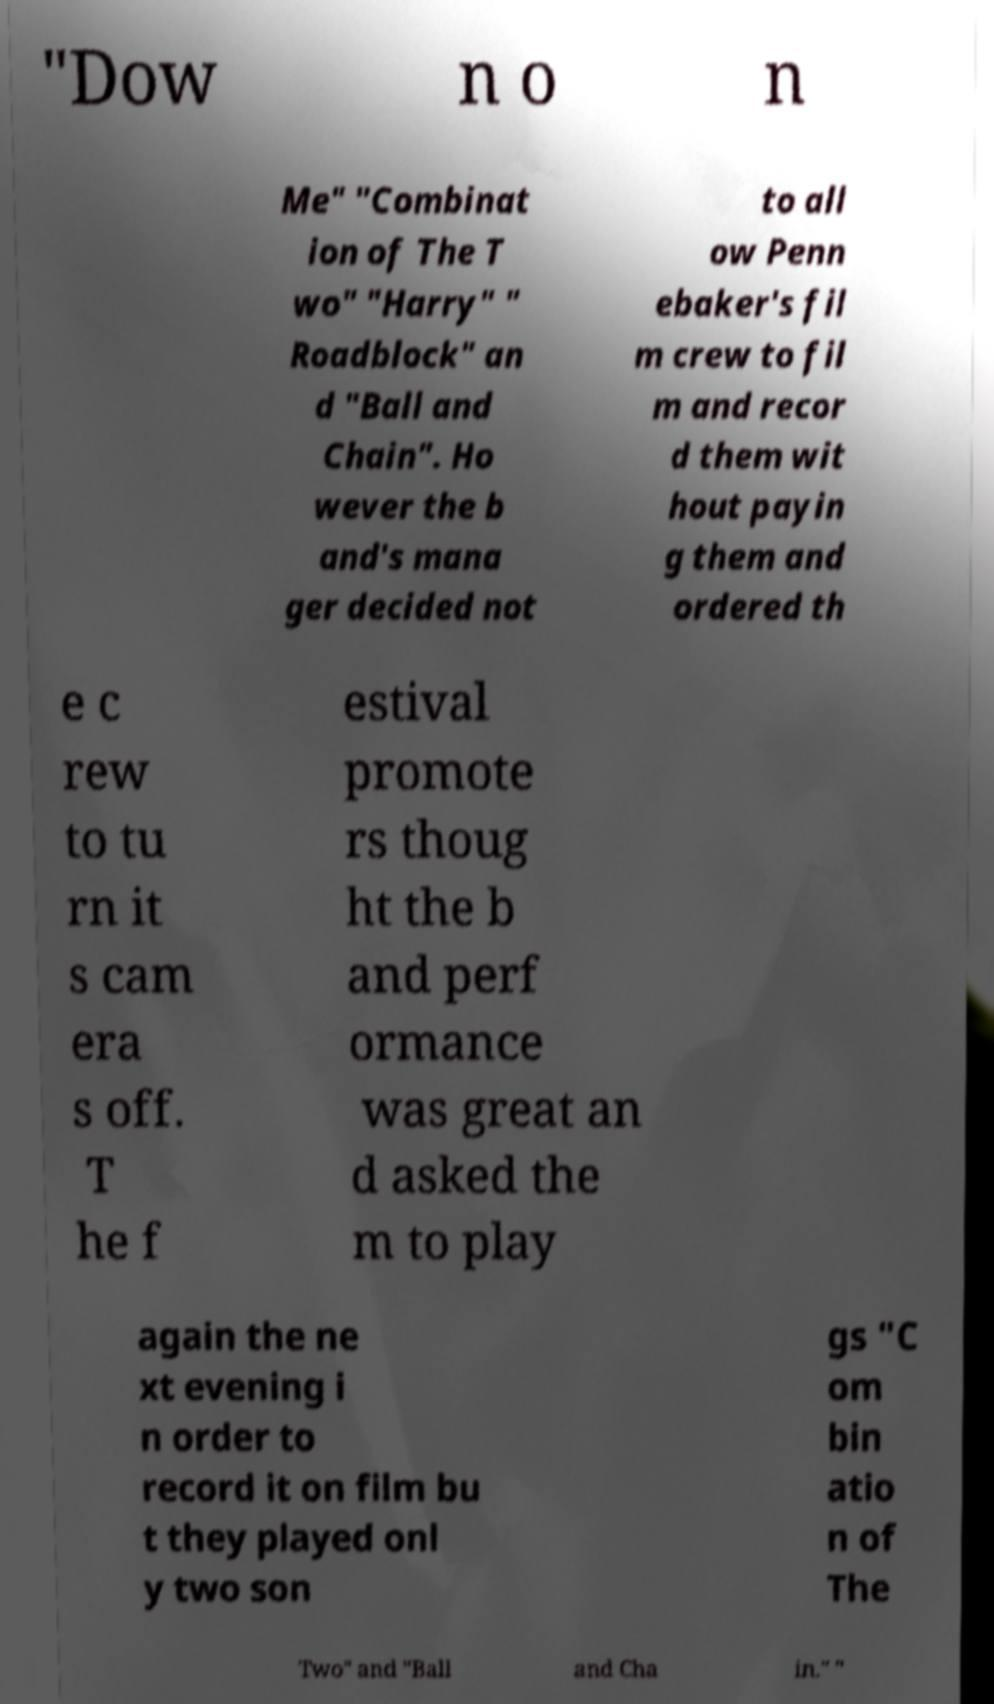Please read and relay the text visible in this image. What does it say? "Dow n o n Me" "Combinat ion of The T wo" "Harry" " Roadblock" an d "Ball and Chain". Ho wever the b and's mana ger decided not to all ow Penn ebaker's fil m crew to fil m and recor d them wit hout payin g them and ordered th e c rew to tu rn it s cam era s off. T he f estival promote rs thoug ht the b and perf ormance was great an d asked the m to play again the ne xt evening i n order to record it on film bu t they played onl y two son gs "C om bin atio n of The Two" and "Ball and Cha in." " 